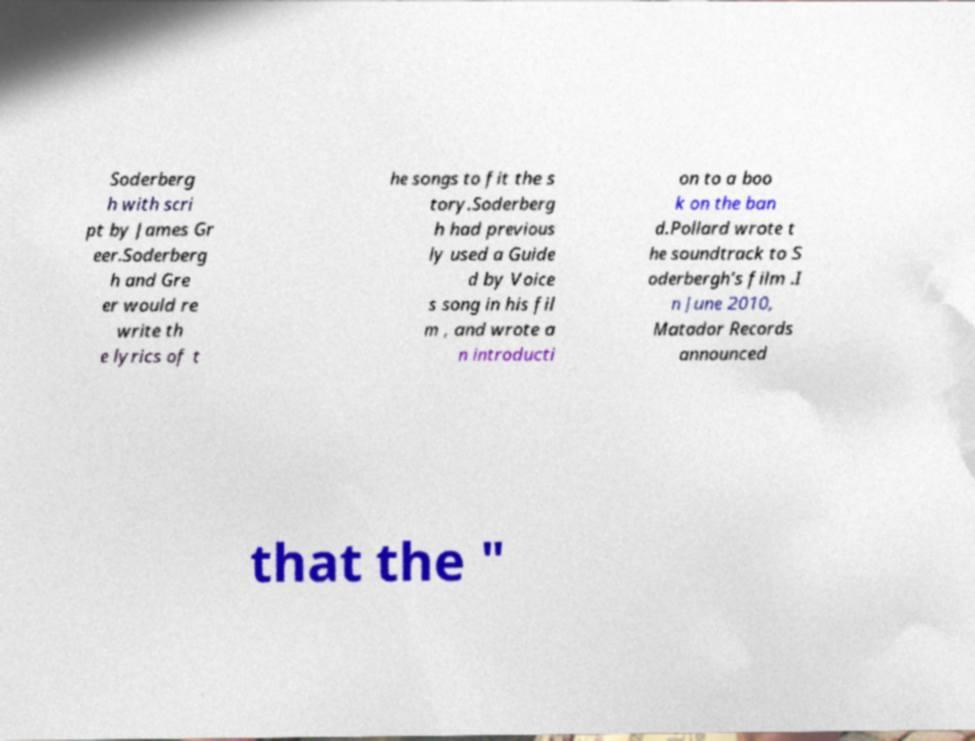Can you accurately transcribe the text from the provided image for me? Soderberg h with scri pt by James Gr eer.Soderberg h and Gre er would re write th e lyrics of t he songs to fit the s tory.Soderberg h had previous ly used a Guide d by Voice s song in his fil m , and wrote a n introducti on to a boo k on the ban d.Pollard wrote t he soundtrack to S oderbergh's film .I n June 2010, Matador Records announced that the " 